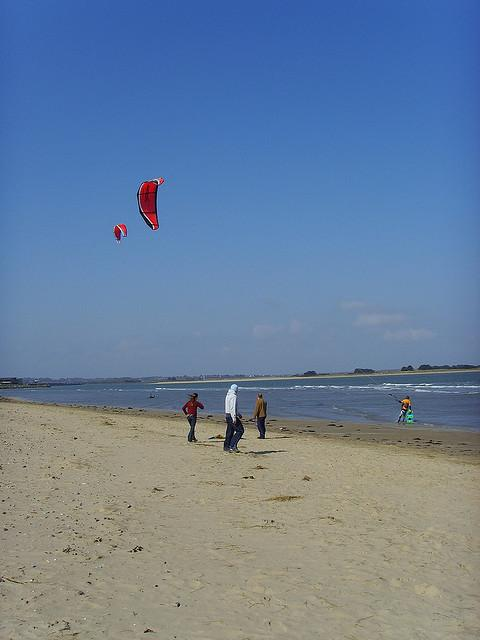What touches the feet of the people holding the airborn sails?

Choices:
A) rock
B) monkeys
C) water
D) people water 